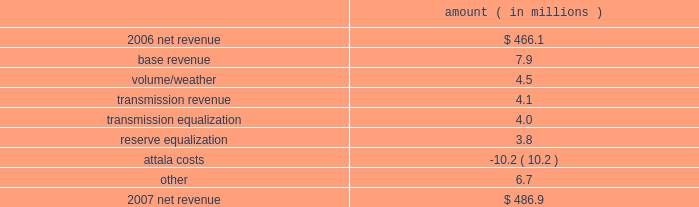Entergy mississippi , inc .
Management's financial discussion and analysis the net wholesale revenue variance is primarily due to lower profit on joint account sales and reduced capacity revenue from the municipal energy agency of mississippi .
Gross operating revenues , fuel and purchased power expenses , and other regulatory charges gross operating revenues increased primarily due to an increase of $ 152.5 million in fuel cost recovery revenues due to higher fuel rates , partially offset by a decrease of $ 43 million in gross wholesale revenues due to a decrease in net generation and purchases in excess of decreased net area demand resulting in less energy available for resale sales coupled with a decrease in system agreement remedy receipts .
Fuel and purchased power expenses increased primarily due to increases in the average market prices of natural gas and purchased power , partially offset by decreased demand and decreased recovery from customers of deferred fuel costs .
Other regulatory charges increased primarily due to increased recovery through the grand gulf rider of grand gulf capacity costs due to higher rates and increased recovery of costs associated with the power management recovery rider .
There is no material effect on net income due to quarterly adjustments to the power management recovery rider .
2007 compared to 2006 net revenue consists of operating revenues net of : 1 ) fuel , fuel-related expenses , and gas purchased for resale , 2 ) purchased power expenses , and 3 ) other regulatory charges ( credits ) .
Following is an analysis of the change in net revenue comparing 2007 to 2006 .
Amount ( in millions ) .
The base revenue variance is primarily due to a formula rate plan increase effective july 2007 .
The formula rate plan filing is discussed further in "state and local rate regulation" below .
The volume/weather variance is primarily due to increased electricity usage primarily in the residential and commercial sectors , including the effect of more favorable weather on billed electric sales in 2007 compared to 2006 .
Billed electricity usage increased 214 gwh .
The increase in usage was partially offset by decreased usage in the industrial sector .
The transmission revenue variance is due to higher rates and the addition of new transmission customers in late 2006 .
The transmission equalization variance is primarily due to a revision made in 2006 of transmission equalization receipts among entergy companies .
The reserve equalization variance is primarily due to a revision in 2006 of reserve equalization payments among entergy companies due to a ferc ruling regarding the inclusion of interruptible loads in reserve .
What is the net change in net revenue in 2007 compare to 2006? 
Computations: (486.9 - 466.1)
Answer: 20.8. 